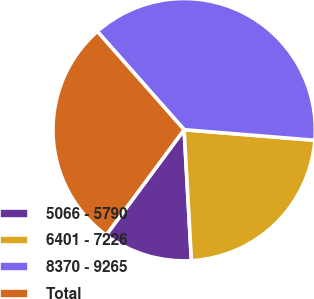Convert chart to OTSL. <chart><loc_0><loc_0><loc_500><loc_500><pie_chart><fcel>5066 - 5790<fcel>6401 - 7226<fcel>8370 - 9265<fcel>Total<nl><fcel>11.02%<fcel>22.83%<fcel>37.8%<fcel>28.35%<nl></chart> 